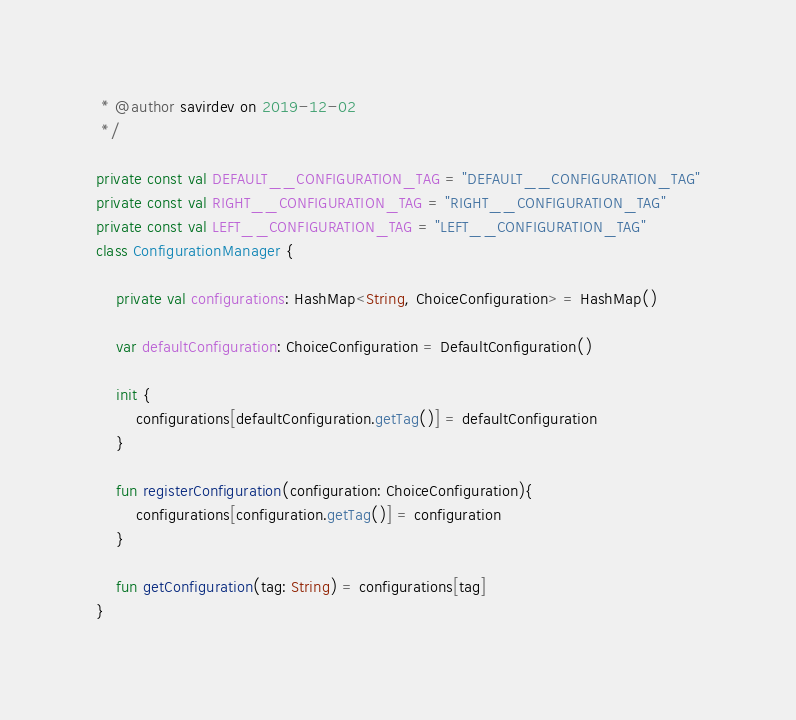<code> <loc_0><loc_0><loc_500><loc_500><_Kotlin_> * @author savirdev on 2019-12-02
 */

private const val DEFAULT__CONFIGURATION_TAG = "DEFAULT__CONFIGURATION_TAG"
private const val RIGHT__CONFIGURATION_TAG = "RIGHT__CONFIGURATION_TAG"
private const val LEFT__CONFIGURATION_TAG = "LEFT__CONFIGURATION_TAG"
class ConfigurationManager {

    private val configurations: HashMap<String, ChoiceConfiguration> = HashMap()

    var defaultConfiguration: ChoiceConfiguration = DefaultConfiguration()

    init {
        configurations[defaultConfiguration.getTag()] = defaultConfiguration
    }

    fun registerConfiguration(configuration: ChoiceConfiguration){
        configurations[configuration.getTag()] = configuration
    }

    fun getConfiguration(tag: String) = configurations[tag]
}</code> 